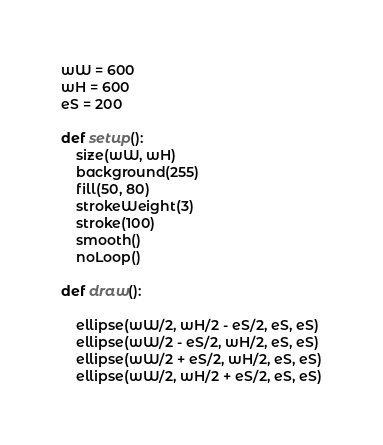Convert code to text. <code><loc_0><loc_0><loc_500><loc_500><_Python_>wW = 600
wH = 600
eS = 200

def setup():
    size(wW, wH)
    background(255)
    fill(50, 80)
    strokeWeight(3)
    stroke(100)
    smooth()
    noLoop()
    
def draw():

    ellipse(wW/2, wH/2 - eS/2, eS, eS)
    ellipse(wW/2 - eS/2, wH/2, eS, eS)
    ellipse(wW/2 + eS/2, wH/2, eS, eS)
    ellipse(wW/2, wH/2 + eS/2, eS, eS)
</code> 